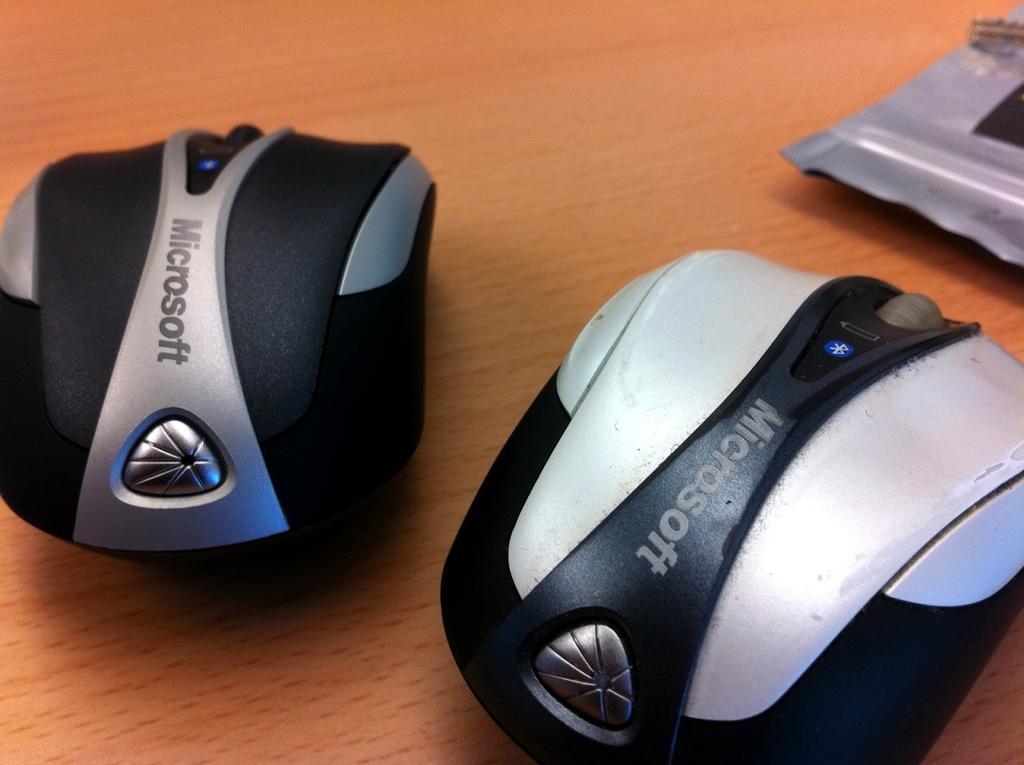Can you describe this image briefly? In this picture we can see few mouses and an object. 